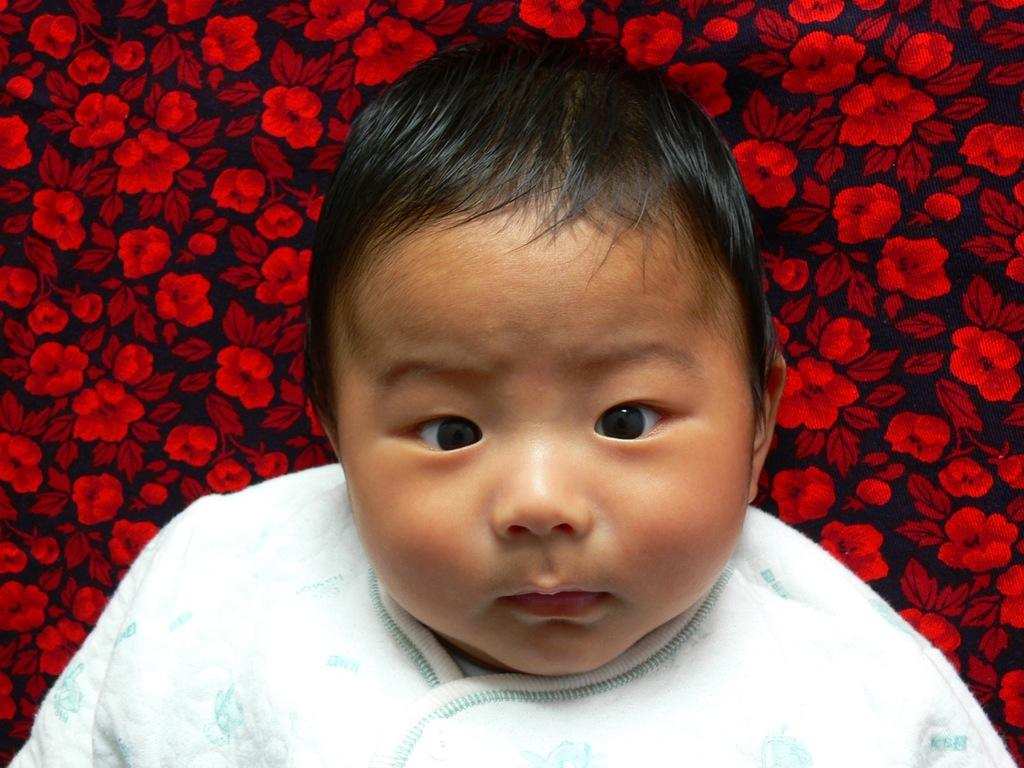What is the main subject of the image? There is a baby in the image. What can be seen behind the baby? There is a floral cloth behind the baby. What type of trail does the baby's grandfather take them on in the image? There is no trail or grandfather present in the image; it only features a baby and a floral cloth. What instrument is the baby playing in the image? There is no instrument present in the image; it only features a baby and a floral cloth. 